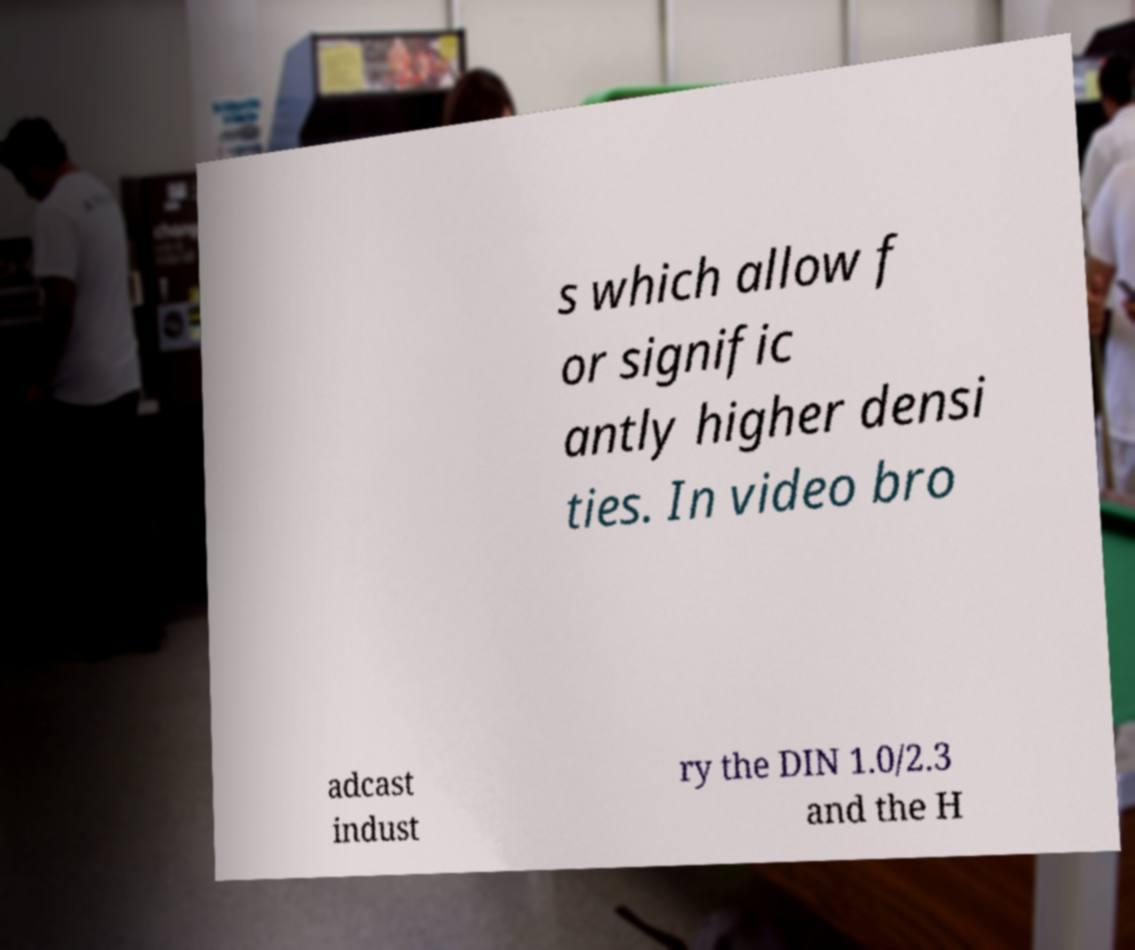Can you read and provide the text displayed in the image?This photo seems to have some interesting text. Can you extract and type it out for me? s which allow f or signific antly higher densi ties. In video bro adcast indust ry the DIN 1.0/2.3 and the H 